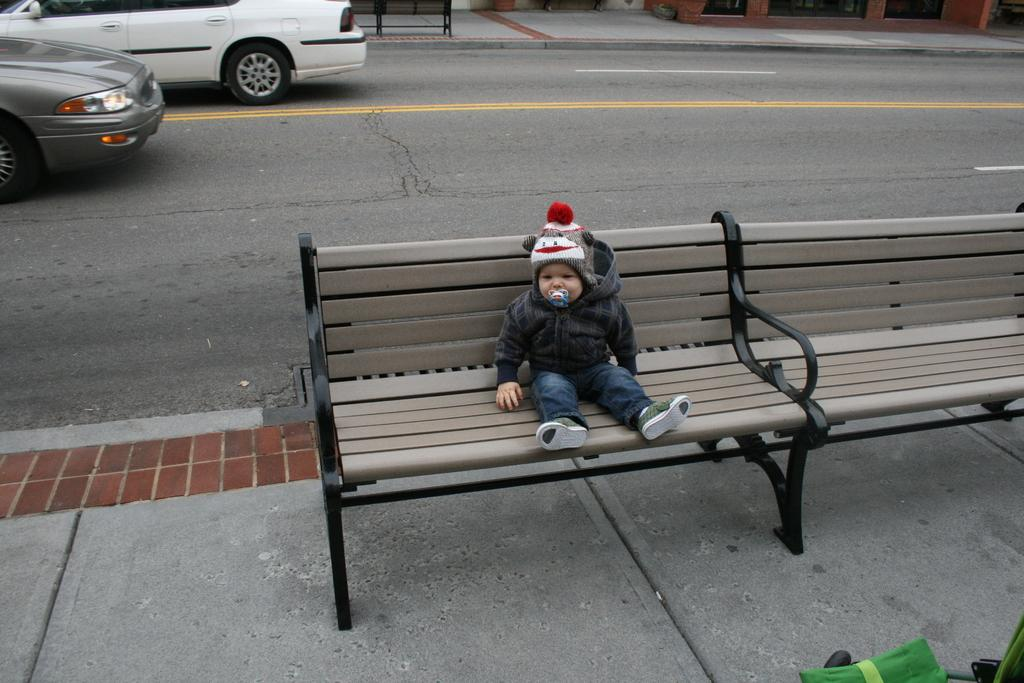What is the boy doing in the image? The boy is sitting on a bench in the image. Where is the bench located? The bench is beside a road. What is happening on the road? There are two cars moving on the road. How much wealth does the snake in the image possess? There is no snake present in the image, so it is not possible to determine its wealth. 